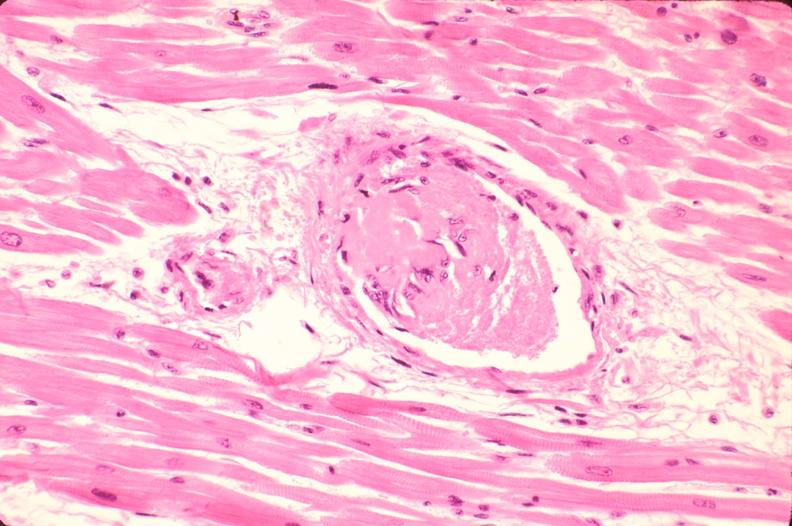what does this image show?
Answer the question using a single word or phrase. Heart 